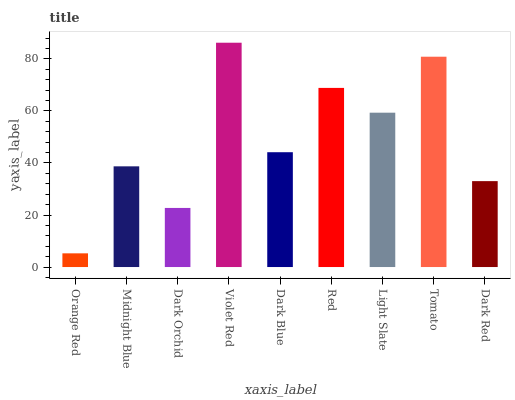Is Orange Red the minimum?
Answer yes or no. Yes. Is Violet Red the maximum?
Answer yes or no. Yes. Is Midnight Blue the minimum?
Answer yes or no. No. Is Midnight Blue the maximum?
Answer yes or no. No. Is Midnight Blue greater than Orange Red?
Answer yes or no. Yes. Is Orange Red less than Midnight Blue?
Answer yes or no. Yes. Is Orange Red greater than Midnight Blue?
Answer yes or no. No. Is Midnight Blue less than Orange Red?
Answer yes or no. No. Is Dark Blue the high median?
Answer yes or no. Yes. Is Dark Blue the low median?
Answer yes or no. Yes. Is Orange Red the high median?
Answer yes or no. No. Is Dark Red the low median?
Answer yes or no. No. 